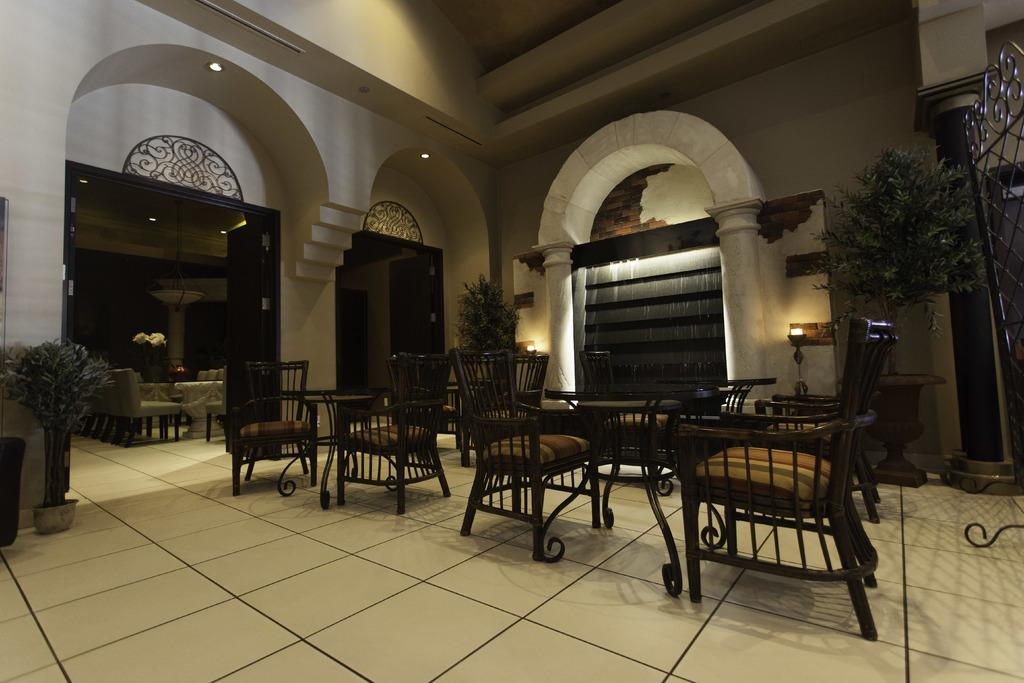What type of furniture is present in the image? There are chairs in the image. How are the chairs arranged in relation to other objects? The chairs are arranged around tables. What can be seen on the roof in the image? There are lights on the roof in the image. How many nails are used to hold the basketball in the image? There is no basketball present in the image, so it is not possible to determine how many nails might be used to hold it. 